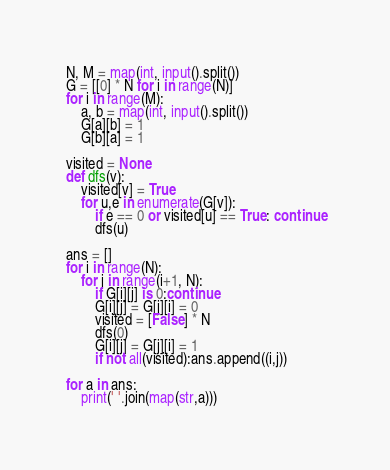<code> <loc_0><loc_0><loc_500><loc_500><_Python_>N, M = map(int, input().split())
G = [[0] * N for i in range(N)]
for i in range(M):
    a, b = map(int, input().split())
    G[a][b] = 1
    G[b][a] = 1

visited = None
def dfs(v):
    visited[v] = True
    for u,e in enumerate(G[v]):
        if e == 0 or visited[u] == True: continue
        dfs(u)
 
ans = []
for i in range(N):
    for j in range(i+1, N):
        if G[i][j] is 0:continue
        G[i][j] = G[j][i] = 0
        visited = [False] * N
        dfs(0)
        G[i][j] = G[j][i] = 1
        if not all(visited):ans.append((i,j))
 
for a in ans:
    print(' '.join(map(str,a)))</code> 